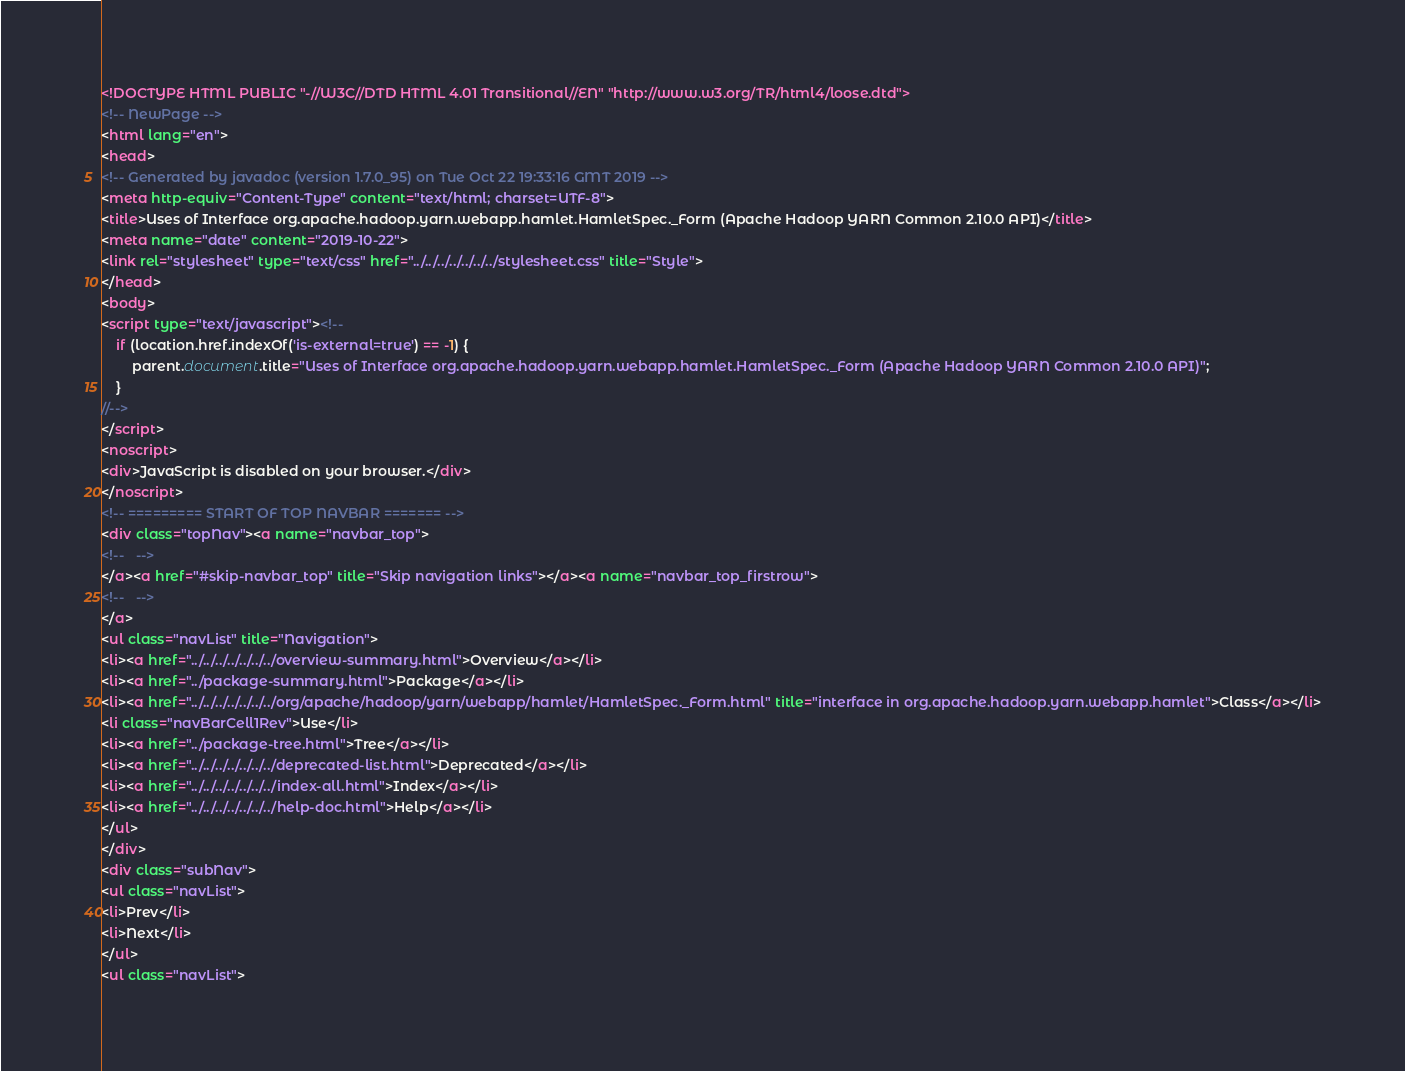<code> <loc_0><loc_0><loc_500><loc_500><_HTML_><!DOCTYPE HTML PUBLIC "-//W3C//DTD HTML 4.01 Transitional//EN" "http://www.w3.org/TR/html4/loose.dtd">
<!-- NewPage -->
<html lang="en">
<head>
<!-- Generated by javadoc (version 1.7.0_95) on Tue Oct 22 19:33:16 GMT 2019 -->
<meta http-equiv="Content-Type" content="text/html; charset=UTF-8">
<title>Uses of Interface org.apache.hadoop.yarn.webapp.hamlet.HamletSpec._Form (Apache Hadoop YARN Common 2.10.0 API)</title>
<meta name="date" content="2019-10-22">
<link rel="stylesheet" type="text/css" href="../../../../../../../stylesheet.css" title="Style">
</head>
<body>
<script type="text/javascript"><!--
    if (location.href.indexOf('is-external=true') == -1) {
        parent.document.title="Uses of Interface org.apache.hadoop.yarn.webapp.hamlet.HamletSpec._Form (Apache Hadoop YARN Common 2.10.0 API)";
    }
//-->
</script>
<noscript>
<div>JavaScript is disabled on your browser.</div>
</noscript>
<!-- ========= START OF TOP NAVBAR ======= -->
<div class="topNav"><a name="navbar_top">
<!--   -->
</a><a href="#skip-navbar_top" title="Skip navigation links"></a><a name="navbar_top_firstrow">
<!--   -->
</a>
<ul class="navList" title="Navigation">
<li><a href="../../../../../../../overview-summary.html">Overview</a></li>
<li><a href="../package-summary.html">Package</a></li>
<li><a href="../../../../../../../org/apache/hadoop/yarn/webapp/hamlet/HamletSpec._Form.html" title="interface in org.apache.hadoop.yarn.webapp.hamlet">Class</a></li>
<li class="navBarCell1Rev">Use</li>
<li><a href="../package-tree.html">Tree</a></li>
<li><a href="../../../../../../../deprecated-list.html">Deprecated</a></li>
<li><a href="../../../../../../../index-all.html">Index</a></li>
<li><a href="../../../../../../../help-doc.html">Help</a></li>
</ul>
</div>
<div class="subNav">
<ul class="navList">
<li>Prev</li>
<li>Next</li>
</ul>
<ul class="navList"></code> 